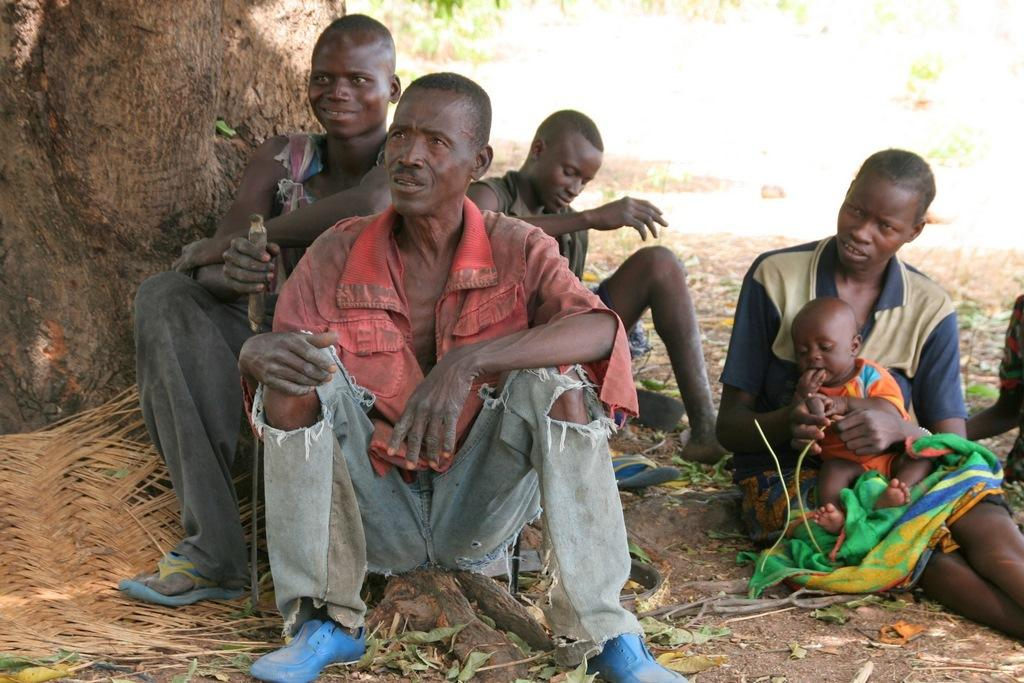How many people are sitting in the image? There are four people sitting in the image. What is one person doing with a baby? One person is holding a baby. What can be seen in the image that is related to nature? There is a tree trunk in the image, and leaves are lying on the ground. Where is the library located in the image? There is no library present in the image. Can you see any ants crawling on the tree trunk in the image? There is no mention of ants in the image, so we cannot determine if any are present. 